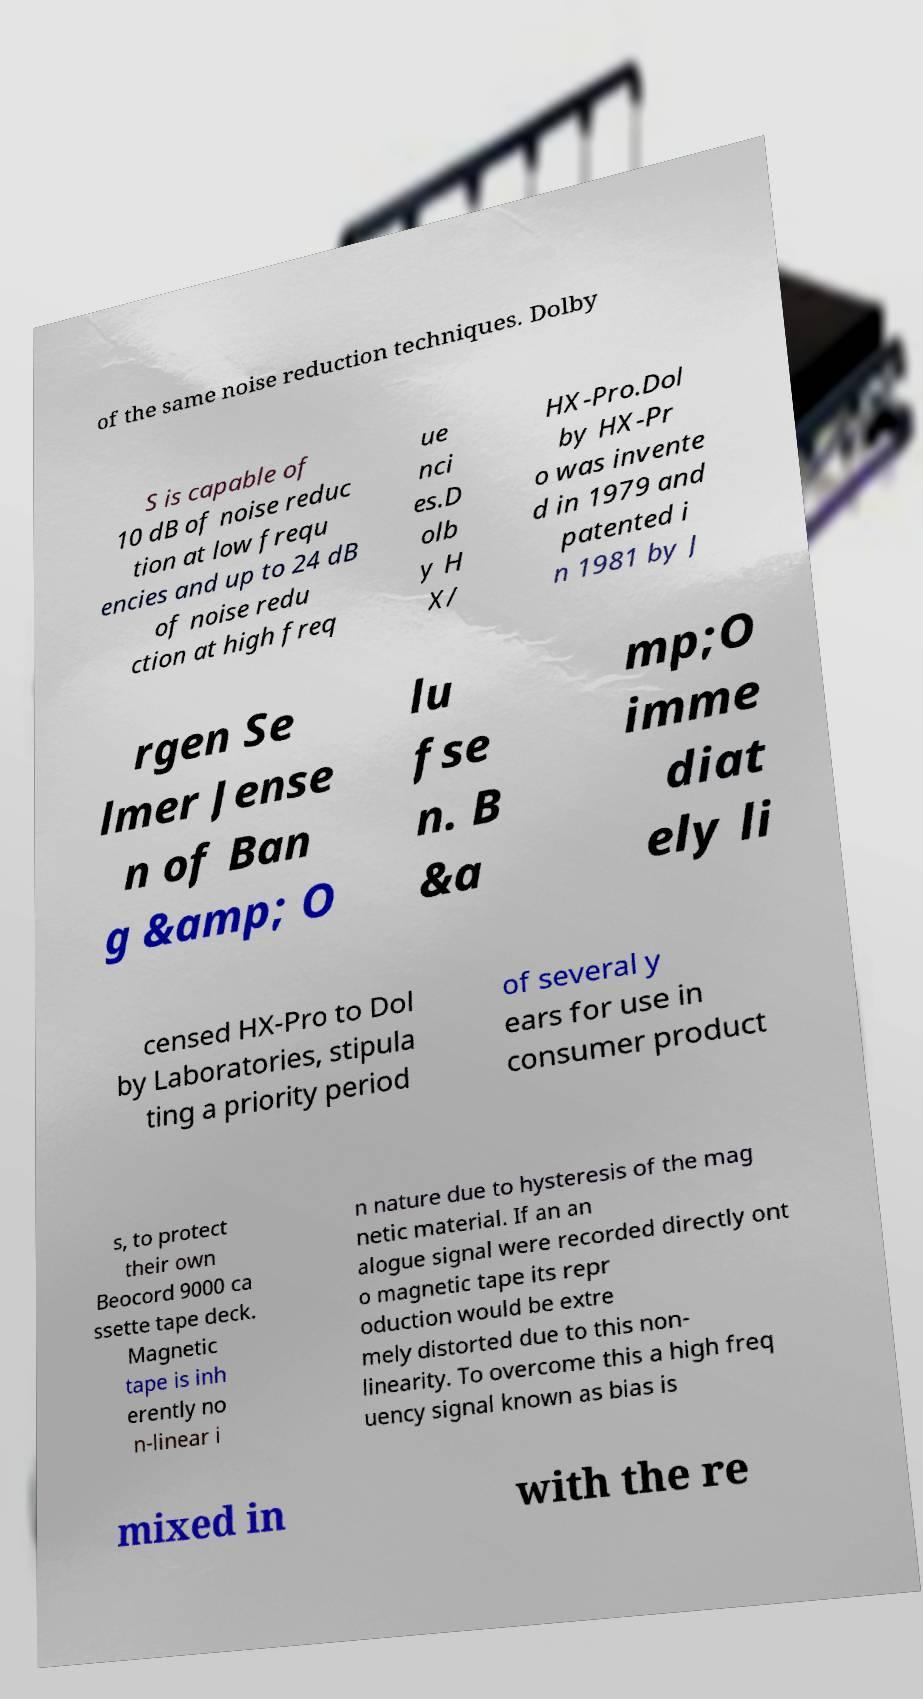Could you assist in decoding the text presented in this image and type it out clearly? of the same noise reduction techniques. Dolby S is capable of 10 dB of noise reduc tion at low frequ encies and up to 24 dB of noise redu ction at high freq ue nci es.D olb y H X/ HX-Pro.Dol by HX-Pr o was invente d in 1979 and patented i n 1981 by J rgen Se lmer Jense n of Ban g &amp; O lu fse n. B &a mp;O imme diat ely li censed HX-Pro to Dol by Laboratories, stipula ting a priority period of several y ears for use in consumer product s, to protect their own Beocord 9000 ca ssette tape deck. Magnetic tape is inh erently no n-linear i n nature due to hysteresis of the mag netic material. If an an alogue signal were recorded directly ont o magnetic tape its repr oduction would be extre mely distorted due to this non- linearity. To overcome this a high freq uency signal known as bias is mixed in with the re 